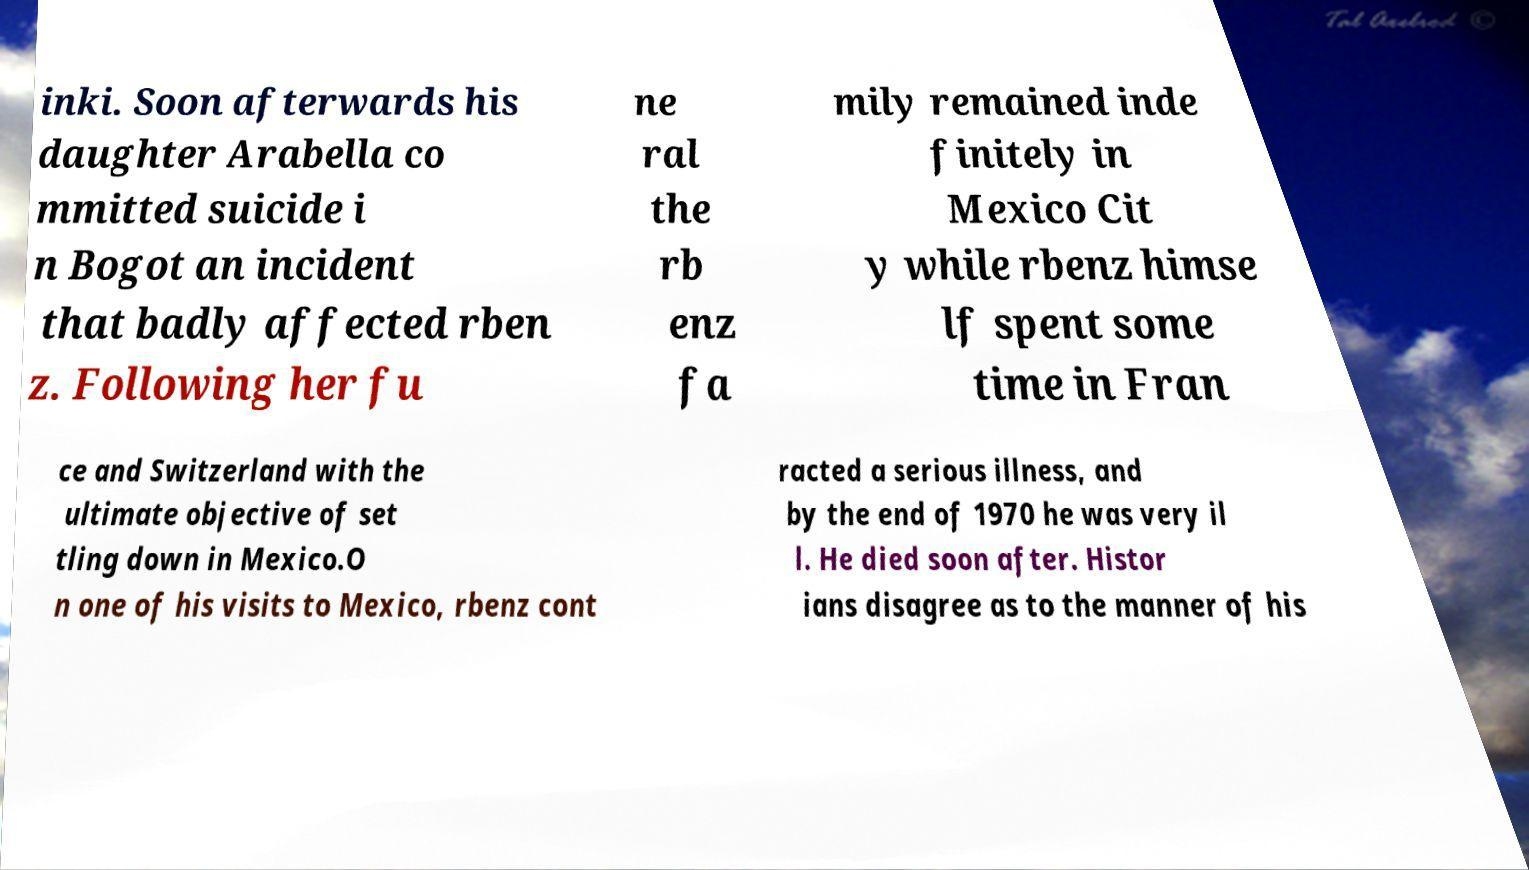What messages or text are displayed in this image? I need them in a readable, typed format. inki. Soon afterwards his daughter Arabella co mmitted suicide i n Bogot an incident that badly affected rben z. Following her fu ne ral the rb enz fa mily remained inde finitely in Mexico Cit y while rbenz himse lf spent some time in Fran ce and Switzerland with the ultimate objective of set tling down in Mexico.O n one of his visits to Mexico, rbenz cont racted a serious illness, and by the end of 1970 he was very il l. He died soon after. Histor ians disagree as to the manner of his 